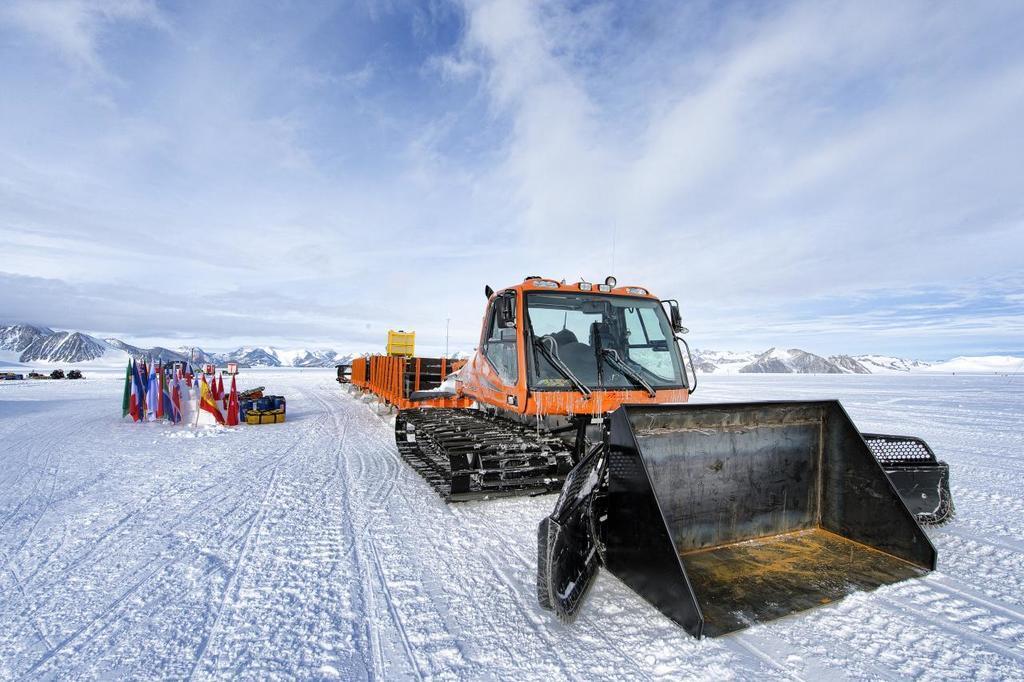Describe this image in one or two sentences. In this image I can see some snow on the ground which is white in color and on the snow I can see a vehicle which is orange and black in color, few flags and few other objects. In the background I can see few mountains, some snow on the mountains and the sky. 